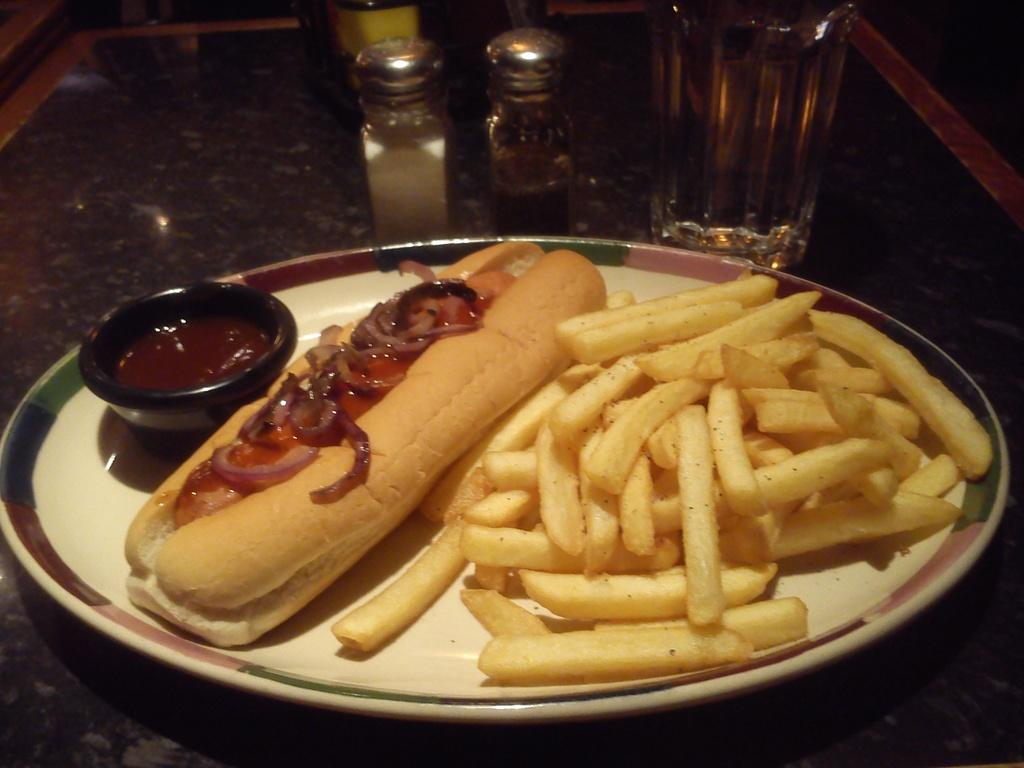What type of food can be seen in the image? There are french fries in the image. What else is present on the plate with the french fries? There is a bun on the plate. What color is the plate that holds the french fries and bun? The plate is white. What is the color of the table on which the plate is placed? The table is brown. What other object can be seen on the table in the image? There is a glass on the table. What type of houses can be seen in the background of the image? There are no houses visible in the image; it only shows french fries, a bun, a plate, a table, and a glass. 